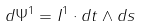<formula> <loc_0><loc_0><loc_500><loc_500>d \Psi ^ { 1 } = I ^ { 1 } \cdot d t \wedge d s</formula> 